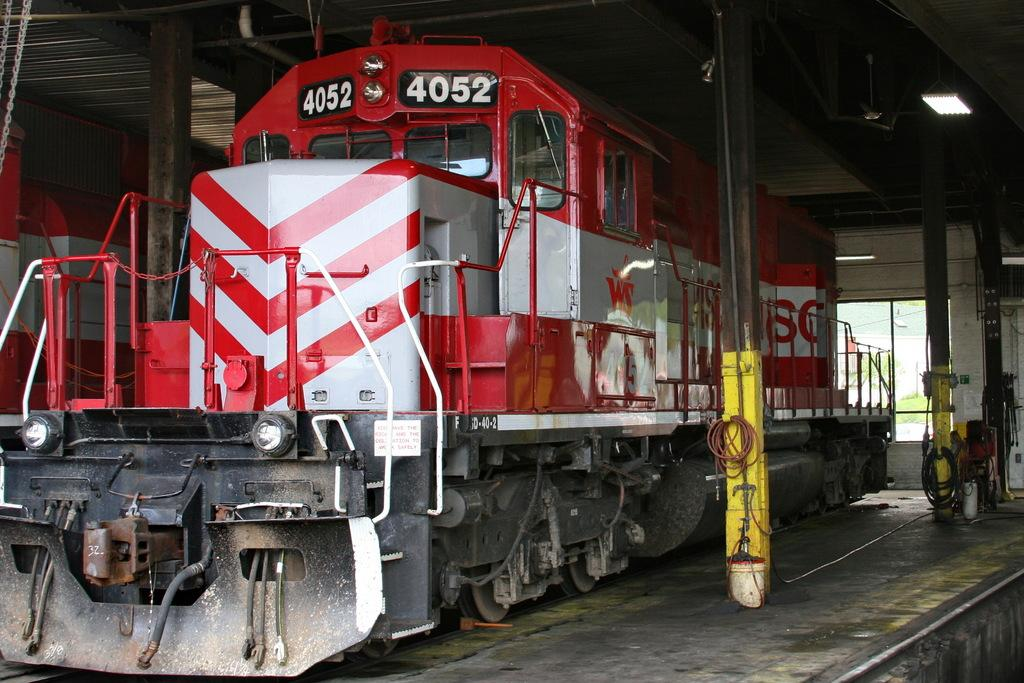What is the main subject of the image? The main subject of the image is a train engine on the track. What other structures can be seen in the image? There are pillars and wires visible in the image. Are there any other train engines in the image? Yes, there is another train engine in the image. Can you see someone using a rake to clean the tracks in the image? No, there is no rake or person cleaning the tracks in the image. 